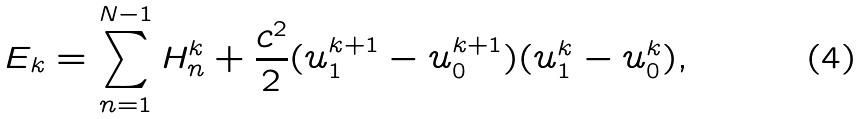Convert formula to latex. <formula><loc_0><loc_0><loc_500><loc_500>E _ { k } = \sum _ { n = 1 } ^ { N - 1 } H _ { n } ^ { k } + \frac { c ^ { 2 } } { 2 } ( u _ { 1 } ^ { k + 1 } - u _ { 0 } ^ { k + 1 } ) ( u _ { 1 } ^ { k } - u _ { 0 } ^ { k } ) ,</formula> 